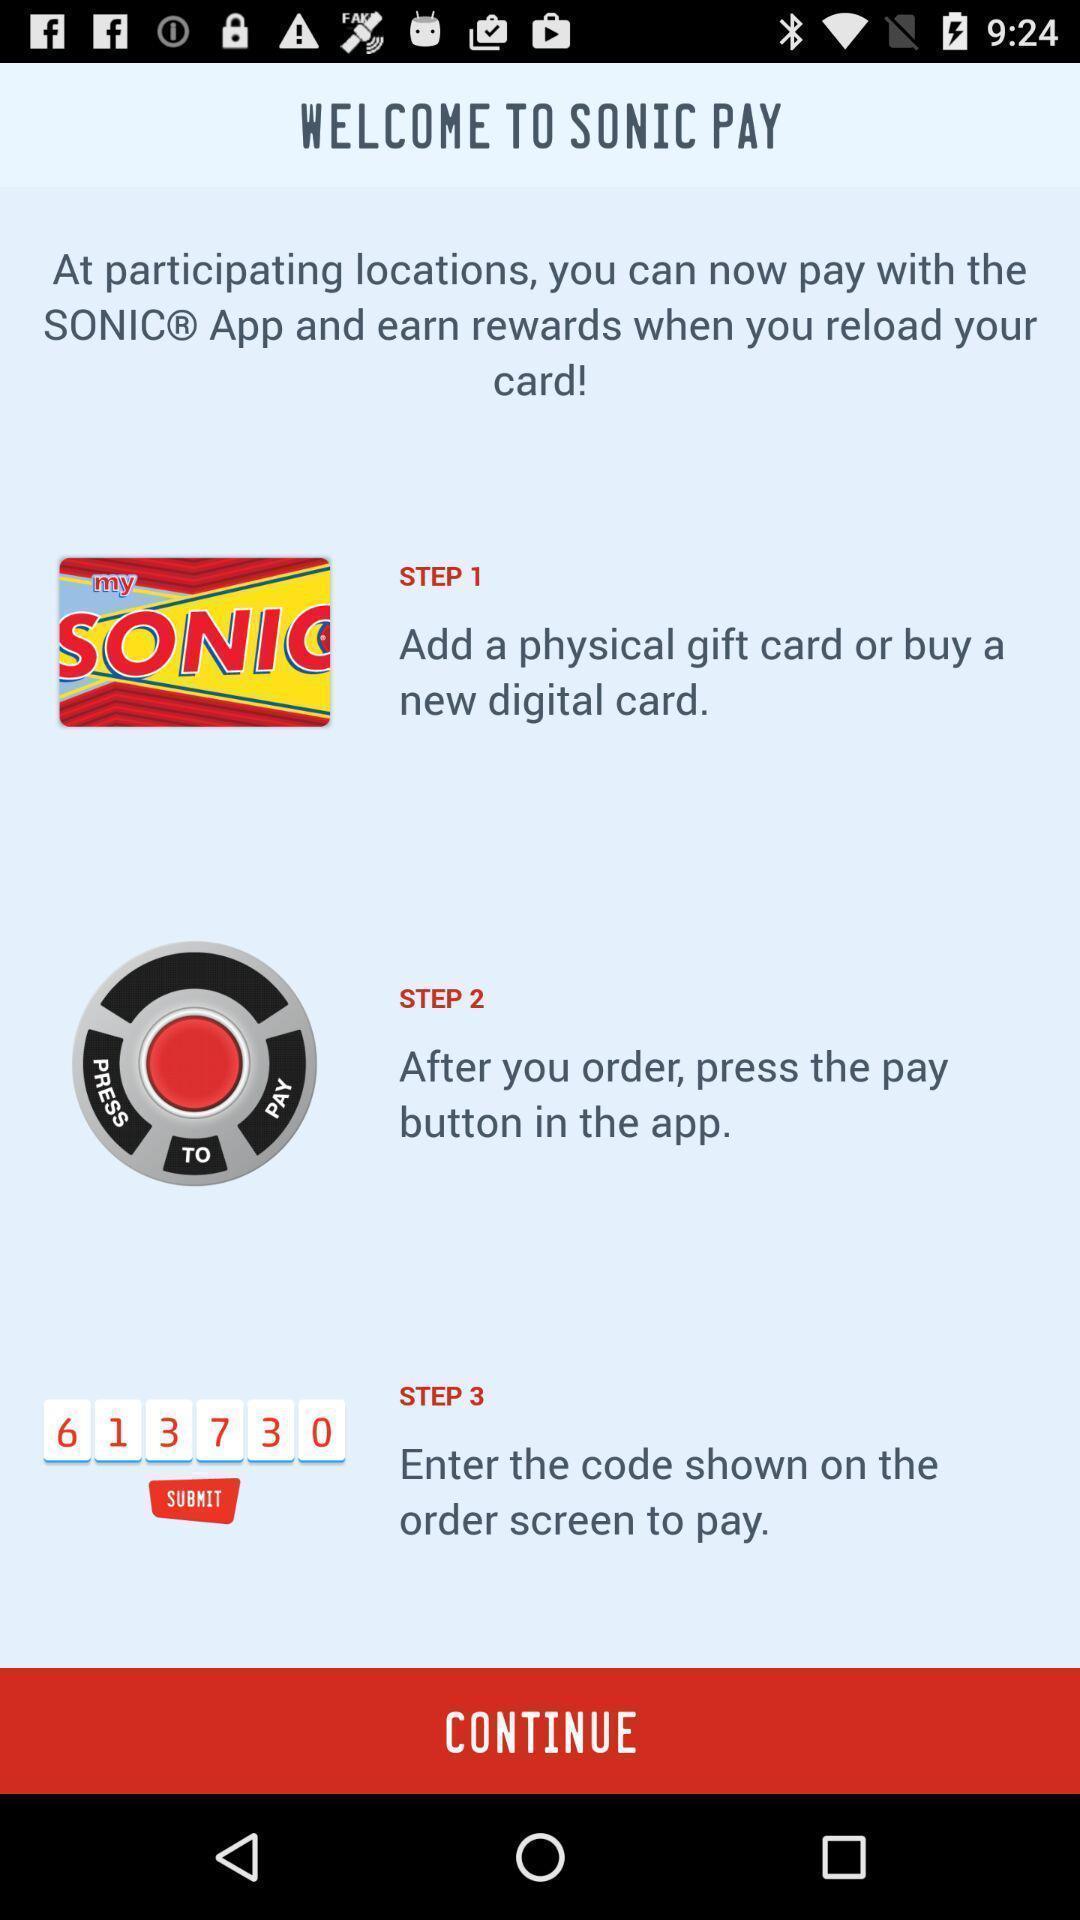Explain what's happening in this screen capture. Welcome page. 